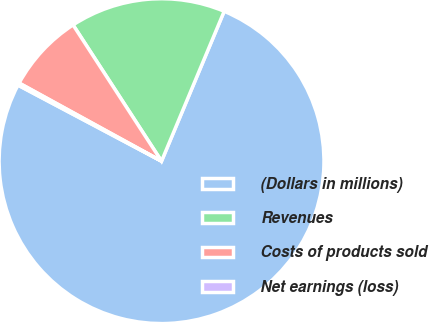Convert chart to OTSL. <chart><loc_0><loc_0><loc_500><loc_500><pie_chart><fcel>(Dollars in millions)<fcel>Revenues<fcel>Costs of products sold<fcel>Net earnings (loss)<nl><fcel>76.45%<fcel>15.47%<fcel>7.85%<fcel>0.23%<nl></chart> 